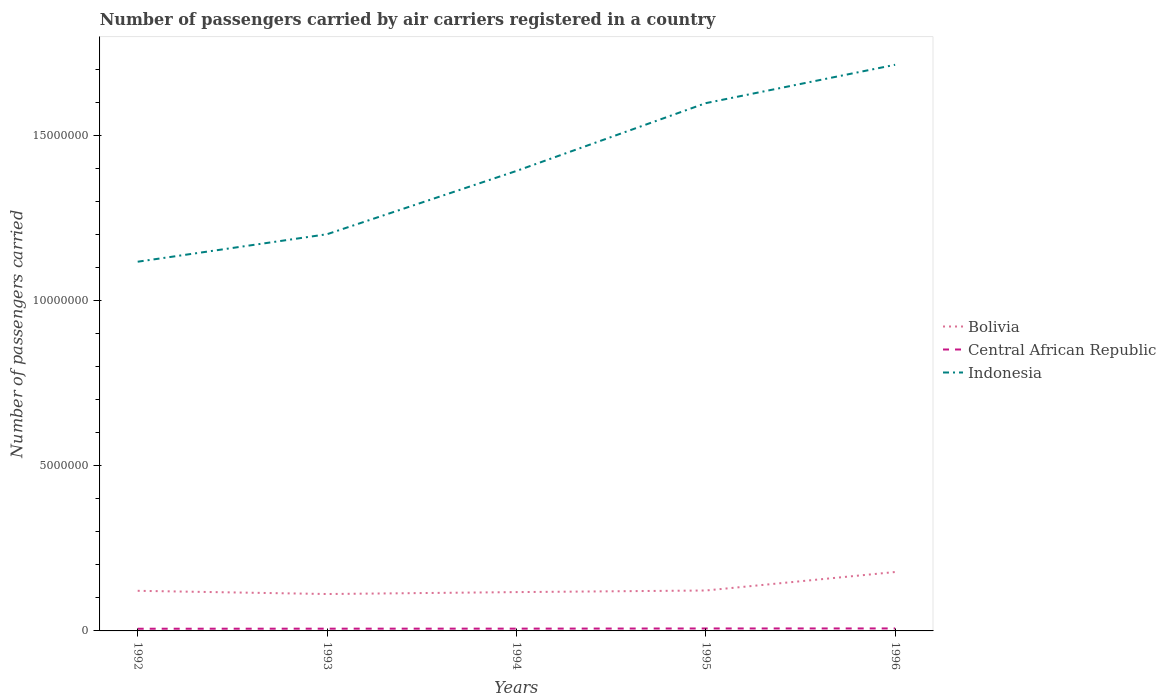Across all years, what is the maximum number of passengers carried by air carriers in Bolivia?
Ensure brevity in your answer.  1.12e+06. What is the total number of passengers carried by air carriers in Bolivia in the graph?
Keep it short and to the point. -5.60e+05. What is the difference between the highest and the second highest number of passengers carried by air carriers in Bolivia?
Your answer should be very brief. 6.66e+05. How many lines are there?
Provide a short and direct response. 3. How many years are there in the graph?
Offer a very short reply. 5. What is the difference between two consecutive major ticks on the Y-axis?
Give a very brief answer. 5.00e+06. Does the graph contain grids?
Ensure brevity in your answer.  No. Where does the legend appear in the graph?
Offer a terse response. Center right. How many legend labels are there?
Provide a succinct answer. 3. How are the legend labels stacked?
Keep it short and to the point. Vertical. What is the title of the graph?
Make the answer very short. Number of passengers carried by air carriers registered in a country. What is the label or title of the Y-axis?
Offer a very short reply. Number of passengers carried. What is the Number of passengers carried of Bolivia in 1992?
Your response must be concise. 1.21e+06. What is the Number of passengers carried of Central African Republic in 1992?
Keep it short and to the point. 6.63e+04. What is the Number of passengers carried of Indonesia in 1992?
Ensure brevity in your answer.  1.12e+07. What is the Number of passengers carried in Bolivia in 1993?
Your answer should be compact. 1.12e+06. What is the Number of passengers carried in Central African Republic in 1993?
Offer a terse response. 6.82e+04. What is the Number of passengers carried of Indonesia in 1993?
Give a very brief answer. 1.20e+07. What is the Number of passengers carried of Bolivia in 1994?
Provide a short and direct response. 1.18e+06. What is the Number of passengers carried in Central African Republic in 1994?
Your answer should be compact. 6.92e+04. What is the Number of passengers carried in Indonesia in 1994?
Provide a succinct answer. 1.39e+07. What is the Number of passengers carried in Bolivia in 1995?
Offer a very short reply. 1.22e+06. What is the Number of passengers carried of Central African Republic in 1995?
Your response must be concise. 7.41e+04. What is the Number of passengers carried of Indonesia in 1995?
Make the answer very short. 1.60e+07. What is the Number of passengers carried of Bolivia in 1996?
Ensure brevity in your answer.  1.78e+06. What is the Number of passengers carried in Central African Republic in 1996?
Provide a succinct answer. 7.51e+04. What is the Number of passengers carried of Indonesia in 1996?
Give a very brief answer. 1.71e+07. Across all years, what is the maximum Number of passengers carried in Bolivia?
Your response must be concise. 1.78e+06. Across all years, what is the maximum Number of passengers carried in Central African Republic?
Keep it short and to the point. 7.51e+04. Across all years, what is the maximum Number of passengers carried of Indonesia?
Your answer should be compact. 1.71e+07. Across all years, what is the minimum Number of passengers carried of Bolivia?
Provide a short and direct response. 1.12e+06. Across all years, what is the minimum Number of passengers carried in Central African Republic?
Provide a succinct answer. 6.63e+04. Across all years, what is the minimum Number of passengers carried in Indonesia?
Your answer should be very brief. 1.12e+07. What is the total Number of passengers carried of Bolivia in the graph?
Give a very brief answer. 6.51e+06. What is the total Number of passengers carried in Central African Republic in the graph?
Your response must be concise. 3.53e+05. What is the total Number of passengers carried in Indonesia in the graph?
Ensure brevity in your answer.  7.02e+07. What is the difference between the Number of passengers carried in Bolivia in 1992 and that in 1993?
Offer a very short reply. 9.74e+04. What is the difference between the Number of passengers carried in Central African Republic in 1992 and that in 1993?
Provide a short and direct response. -1900. What is the difference between the Number of passengers carried in Indonesia in 1992 and that in 1993?
Provide a succinct answer. -8.32e+05. What is the difference between the Number of passengers carried of Bolivia in 1992 and that in 1994?
Provide a succinct answer. 3.92e+04. What is the difference between the Number of passengers carried in Central African Republic in 1992 and that in 1994?
Ensure brevity in your answer.  -2900. What is the difference between the Number of passengers carried in Indonesia in 1992 and that in 1994?
Offer a very short reply. -2.75e+06. What is the difference between the Number of passengers carried of Bolivia in 1992 and that in 1995?
Ensure brevity in your answer.  -9300. What is the difference between the Number of passengers carried in Central African Republic in 1992 and that in 1995?
Your response must be concise. -7800. What is the difference between the Number of passengers carried in Indonesia in 1992 and that in 1995?
Your response must be concise. -4.80e+06. What is the difference between the Number of passengers carried in Bolivia in 1992 and that in 1996?
Your answer should be very brief. -5.69e+05. What is the difference between the Number of passengers carried of Central African Republic in 1992 and that in 1996?
Offer a very short reply. -8800. What is the difference between the Number of passengers carried in Indonesia in 1992 and that in 1996?
Ensure brevity in your answer.  -5.96e+06. What is the difference between the Number of passengers carried of Bolivia in 1993 and that in 1994?
Your answer should be very brief. -5.82e+04. What is the difference between the Number of passengers carried of Central African Republic in 1993 and that in 1994?
Provide a succinct answer. -1000. What is the difference between the Number of passengers carried in Indonesia in 1993 and that in 1994?
Offer a terse response. -1.92e+06. What is the difference between the Number of passengers carried in Bolivia in 1993 and that in 1995?
Keep it short and to the point. -1.07e+05. What is the difference between the Number of passengers carried in Central African Republic in 1993 and that in 1995?
Ensure brevity in your answer.  -5900. What is the difference between the Number of passengers carried of Indonesia in 1993 and that in 1995?
Offer a very short reply. -3.97e+06. What is the difference between the Number of passengers carried of Bolivia in 1993 and that in 1996?
Your answer should be compact. -6.66e+05. What is the difference between the Number of passengers carried of Central African Republic in 1993 and that in 1996?
Your response must be concise. -6900. What is the difference between the Number of passengers carried in Indonesia in 1993 and that in 1996?
Ensure brevity in your answer.  -5.13e+06. What is the difference between the Number of passengers carried in Bolivia in 1994 and that in 1995?
Your answer should be very brief. -4.85e+04. What is the difference between the Number of passengers carried in Central African Republic in 1994 and that in 1995?
Your answer should be compact. -4900. What is the difference between the Number of passengers carried in Indonesia in 1994 and that in 1995?
Ensure brevity in your answer.  -2.05e+06. What is the difference between the Number of passengers carried in Bolivia in 1994 and that in 1996?
Offer a very short reply. -6.08e+05. What is the difference between the Number of passengers carried of Central African Republic in 1994 and that in 1996?
Offer a very short reply. -5900. What is the difference between the Number of passengers carried of Indonesia in 1994 and that in 1996?
Your response must be concise. -3.21e+06. What is the difference between the Number of passengers carried of Bolivia in 1995 and that in 1996?
Your answer should be compact. -5.60e+05. What is the difference between the Number of passengers carried of Central African Republic in 1995 and that in 1996?
Your response must be concise. -1000. What is the difference between the Number of passengers carried in Indonesia in 1995 and that in 1996?
Your answer should be very brief. -1.16e+06. What is the difference between the Number of passengers carried in Bolivia in 1992 and the Number of passengers carried in Central African Republic in 1993?
Your answer should be very brief. 1.15e+06. What is the difference between the Number of passengers carried in Bolivia in 1992 and the Number of passengers carried in Indonesia in 1993?
Your response must be concise. -1.08e+07. What is the difference between the Number of passengers carried of Central African Republic in 1992 and the Number of passengers carried of Indonesia in 1993?
Make the answer very short. -1.19e+07. What is the difference between the Number of passengers carried in Bolivia in 1992 and the Number of passengers carried in Central African Republic in 1994?
Ensure brevity in your answer.  1.15e+06. What is the difference between the Number of passengers carried in Bolivia in 1992 and the Number of passengers carried in Indonesia in 1994?
Give a very brief answer. -1.27e+07. What is the difference between the Number of passengers carried in Central African Republic in 1992 and the Number of passengers carried in Indonesia in 1994?
Your response must be concise. -1.39e+07. What is the difference between the Number of passengers carried in Bolivia in 1992 and the Number of passengers carried in Central African Republic in 1995?
Offer a terse response. 1.14e+06. What is the difference between the Number of passengers carried in Bolivia in 1992 and the Number of passengers carried in Indonesia in 1995?
Your answer should be very brief. -1.48e+07. What is the difference between the Number of passengers carried of Central African Republic in 1992 and the Number of passengers carried of Indonesia in 1995?
Offer a very short reply. -1.59e+07. What is the difference between the Number of passengers carried in Bolivia in 1992 and the Number of passengers carried in Central African Republic in 1996?
Your answer should be very brief. 1.14e+06. What is the difference between the Number of passengers carried in Bolivia in 1992 and the Number of passengers carried in Indonesia in 1996?
Your answer should be compact. -1.59e+07. What is the difference between the Number of passengers carried of Central African Republic in 1992 and the Number of passengers carried of Indonesia in 1996?
Offer a very short reply. -1.71e+07. What is the difference between the Number of passengers carried in Bolivia in 1993 and the Number of passengers carried in Central African Republic in 1994?
Your answer should be compact. 1.05e+06. What is the difference between the Number of passengers carried in Bolivia in 1993 and the Number of passengers carried in Indonesia in 1994?
Offer a terse response. -1.28e+07. What is the difference between the Number of passengers carried in Central African Republic in 1993 and the Number of passengers carried in Indonesia in 1994?
Keep it short and to the point. -1.39e+07. What is the difference between the Number of passengers carried in Bolivia in 1993 and the Number of passengers carried in Central African Republic in 1995?
Ensure brevity in your answer.  1.04e+06. What is the difference between the Number of passengers carried of Bolivia in 1993 and the Number of passengers carried of Indonesia in 1995?
Give a very brief answer. -1.49e+07. What is the difference between the Number of passengers carried of Central African Republic in 1993 and the Number of passengers carried of Indonesia in 1995?
Offer a terse response. -1.59e+07. What is the difference between the Number of passengers carried in Bolivia in 1993 and the Number of passengers carried in Central African Republic in 1996?
Provide a succinct answer. 1.04e+06. What is the difference between the Number of passengers carried of Bolivia in 1993 and the Number of passengers carried of Indonesia in 1996?
Provide a succinct answer. -1.60e+07. What is the difference between the Number of passengers carried in Central African Republic in 1993 and the Number of passengers carried in Indonesia in 1996?
Provide a succinct answer. -1.71e+07. What is the difference between the Number of passengers carried in Bolivia in 1994 and the Number of passengers carried in Central African Republic in 1995?
Provide a succinct answer. 1.10e+06. What is the difference between the Number of passengers carried in Bolivia in 1994 and the Number of passengers carried in Indonesia in 1995?
Your answer should be compact. -1.48e+07. What is the difference between the Number of passengers carried of Central African Republic in 1994 and the Number of passengers carried of Indonesia in 1995?
Ensure brevity in your answer.  -1.59e+07. What is the difference between the Number of passengers carried of Bolivia in 1994 and the Number of passengers carried of Central African Republic in 1996?
Make the answer very short. 1.10e+06. What is the difference between the Number of passengers carried of Bolivia in 1994 and the Number of passengers carried of Indonesia in 1996?
Provide a short and direct response. -1.60e+07. What is the difference between the Number of passengers carried of Central African Republic in 1994 and the Number of passengers carried of Indonesia in 1996?
Provide a succinct answer. -1.71e+07. What is the difference between the Number of passengers carried of Bolivia in 1995 and the Number of passengers carried of Central African Republic in 1996?
Offer a very short reply. 1.15e+06. What is the difference between the Number of passengers carried of Bolivia in 1995 and the Number of passengers carried of Indonesia in 1996?
Ensure brevity in your answer.  -1.59e+07. What is the difference between the Number of passengers carried of Central African Republic in 1995 and the Number of passengers carried of Indonesia in 1996?
Offer a terse response. -1.71e+07. What is the average Number of passengers carried in Bolivia per year?
Ensure brevity in your answer.  1.30e+06. What is the average Number of passengers carried in Central African Republic per year?
Provide a succinct answer. 7.06e+04. What is the average Number of passengers carried of Indonesia per year?
Provide a short and direct response. 1.40e+07. In the year 1992, what is the difference between the Number of passengers carried in Bolivia and Number of passengers carried in Central African Republic?
Offer a terse response. 1.15e+06. In the year 1992, what is the difference between the Number of passengers carried of Bolivia and Number of passengers carried of Indonesia?
Offer a terse response. -9.96e+06. In the year 1992, what is the difference between the Number of passengers carried of Central African Republic and Number of passengers carried of Indonesia?
Your response must be concise. -1.11e+07. In the year 1993, what is the difference between the Number of passengers carried of Bolivia and Number of passengers carried of Central African Republic?
Your answer should be very brief. 1.05e+06. In the year 1993, what is the difference between the Number of passengers carried of Bolivia and Number of passengers carried of Indonesia?
Make the answer very short. -1.09e+07. In the year 1993, what is the difference between the Number of passengers carried of Central African Republic and Number of passengers carried of Indonesia?
Give a very brief answer. -1.19e+07. In the year 1994, what is the difference between the Number of passengers carried in Bolivia and Number of passengers carried in Central African Republic?
Give a very brief answer. 1.11e+06. In the year 1994, what is the difference between the Number of passengers carried in Bolivia and Number of passengers carried in Indonesia?
Provide a succinct answer. -1.27e+07. In the year 1994, what is the difference between the Number of passengers carried of Central African Republic and Number of passengers carried of Indonesia?
Offer a terse response. -1.39e+07. In the year 1995, what is the difference between the Number of passengers carried in Bolivia and Number of passengers carried in Central African Republic?
Keep it short and to the point. 1.15e+06. In the year 1995, what is the difference between the Number of passengers carried of Bolivia and Number of passengers carried of Indonesia?
Ensure brevity in your answer.  -1.48e+07. In the year 1995, what is the difference between the Number of passengers carried in Central African Republic and Number of passengers carried in Indonesia?
Your response must be concise. -1.59e+07. In the year 1996, what is the difference between the Number of passengers carried in Bolivia and Number of passengers carried in Central African Republic?
Offer a terse response. 1.71e+06. In the year 1996, what is the difference between the Number of passengers carried of Bolivia and Number of passengers carried of Indonesia?
Your answer should be very brief. -1.54e+07. In the year 1996, what is the difference between the Number of passengers carried of Central African Republic and Number of passengers carried of Indonesia?
Ensure brevity in your answer.  -1.71e+07. What is the ratio of the Number of passengers carried of Bolivia in 1992 to that in 1993?
Your answer should be compact. 1.09. What is the ratio of the Number of passengers carried in Central African Republic in 1992 to that in 1993?
Provide a short and direct response. 0.97. What is the ratio of the Number of passengers carried in Indonesia in 1992 to that in 1993?
Your answer should be very brief. 0.93. What is the ratio of the Number of passengers carried of Bolivia in 1992 to that in 1994?
Keep it short and to the point. 1.03. What is the ratio of the Number of passengers carried of Central African Republic in 1992 to that in 1994?
Offer a very short reply. 0.96. What is the ratio of the Number of passengers carried of Indonesia in 1992 to that in 1994?
Your response must be concise. 0.8. What is the ratio of the Number of passengers carried of Central African Republic in 1992 to that in 1995?
Your answer should be very brief. 0.89. What is the ratio of the Number of passengers carried in Indonesia in 1992 to that in 1995?
Offer a very short reply. 0.7. What is the ratio of the Number of passengers carried in Bolivia in 1992 to that in 1996?
Offer a very short reply. 0.68. What is the ratio of the Number of passengers carried in Central African Republic in 1992 to that in 1996?
Your answer should be very brief. 0.88. What is the ratio of the Number of passengers carried of Indonesia in 1992 to that in 1996?
Offer a very short reply. 0.65. What is the ratio of the Number of passengers carried in Bolivia in 1993 to that in 1994?
Offer a very short reply. 0.95. What is the ratio of the Number of passengers carried of Central African Republic in 1993 to that in 1994?
Offer a terse response. 0.99. What is the ratio of the Number of passengers carried in Indonesia in 1993 to that in 1994?
Make the answer very short. 0.86. What is the ratio of the Number of passengers carried in Bolivia in 1993 to that in 1995?
Offer a terse response. 0.91. What is the ratio of the Number of passengers carried of Central African Republic in 1993 to that in 1995?
Your answer should be very brief. 0.92. What is the ratio of the Number of passengers carried of Indonesia in 1993 to that in 1995?
Offer a terse response. 0.75. What is the ratio of the Number of passengers carried of Bolivia in 1993 to that in 1996?
Keep it short and to the point. 0.63. What is the ratio of the Number of passengers carried of Central African Republic in 1993 to that in 1996?
Your answer should be very brief. 0.91. What is the ratio of the Number of passengers carried of Indonesia in 1993 to that in 1996?
Provide a succinct answer. 0.7. What is the ratio of the Number of passengers carried in Bolivia in 1994 to that in 1995?
Your response must be concise. 0.96. What is the ratio of the Number of passengers carried of Central African Republic in 1994 to that in 1995?
Keep it short and to the point. 0.93. What is the ratio of the Number of passengers carried in Indonesia in 1994 to that in 1995?
Provide a short and direct response. 0.87. What is the ratio of the Number of passengers carried of Bolivia in 1994 to that in 1996?
Provide a succinct answer. 0.66. What is the ratio of the Number of passengers carried in Central African Republic in 1994 to that in 1996?
Provide a short and direct response. 0.92. What is the ratio of the Number of passengers carried of Indonesia in 1994 to that in 1996?
Give a very brief answer. 0.81. What is the ratio of the Number of passengers carried of Bolivia in 1995 to that in 1996?
Your response must be concise. 0.69. What is the ratio of the Number of passengers carried in Central African Republic in 1995 to that in 1996?
Your answer should be compact. 0.99. What is the ratio of the Number of passengers carried of Indonesia in 1995 to that in 1996?
Keep it short and to the point. 0.93. What is the difference between the highest and the second highest Number of passengers carried in Bolivia?
Ensure brevity in your answer.  5.60e+05. What is the difference between the highest and the second highest Number of passengers carried in Central African Republic?
Provide a succinct answer. 1000. What is the difference between the highest and the second highest Number of passengers carried of Indonesia?
Provide a short and direct response. 1.16e+06. What is the difference between the highest and the lowest Number of passengers carried of Bolivia?
Make the answer very short. 6.66e+05. What is the difference between the highest and the lowest Number of passengers carried of Central African Republic?
Your answer should be very brief. 8800. What is the difference between the highest and the lowest Number of passengers carried of Indonesia?
Provide a succinct answer. 5.96e+06. 